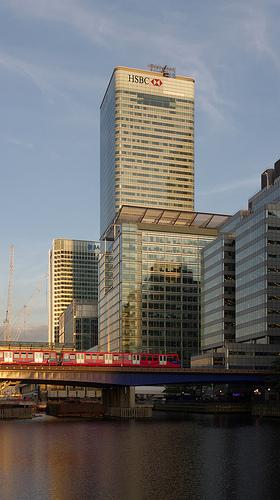Identify any modes of transportation visible in the image. A train is the primary mode of transportation visible in the image. Mention an object in the image that has two different colors. A red and blue train is an object with two colors in the image. Estimate the dimensions of the tall building in the picture. The tall building is approximately 80 units wide and 80 units high. What type of scene is predominantly in the image? An urban scene with a train on a bridge, tall building, and a clear blue sky. What is a remarkable aspect visible in the lower part of the image? A noticeable reflection of a bridge appears in the water below it. Please tell me what you see on the train in this image. A red and blue train with a white door on it, crossing a bridge. What interactions can be observed between different objects in the image? Interactions include the train crossing the bridge, the reflection of the bridge in the water, and a crane near a tall building. What emotions might a viewer of this image feel? The viewer might feel a sense of calm due to the clear blue sky and water or excitement from the train crossing the bridge. Count the number of clouds in the image. The image has 13 individual clouds captured in it. Can you identify the primary colors present in the sky of this image? Blue and white are the primary colors in this image's sky, with white clouds scattered throughout. Is there a graffiti artwork on the tall building located at coordinates X:122, Y:70, Width:80, Height:80? The given information only indicates that there's a tall building, without making any reference to graffiti artwork. Hence, mentioning graffiti on the building is misleading. What type of door is found on the train? A white door Select the phrase that correctly describes an object in the image: "orange bike," "white and orange crane," "pink car." White and orange crane What is the main event happening in this scene? A red and blue train passing over a blue railroad bridge. What appears under the bridge in the image? There's another bridge under the bridge. Is there a reflection in the windows and water in the image? Yes, there is a reflection in both the windows and the water. Which of these objects is present in the image: a boat, a train, a bicycle? A train Is there a train in the image? If so, what colors are present on the train? Yes, there is a train in the image. It is red and blue. Do the white clouds appear in different parts of the sky in the image? Yes, the white clouds appear in various parts of the blue sky. Which object in the image best represents the color blue? Blue railroad bridge Is the sky filled with clouds? Yes, there are white clouds in the blue sky. Is there a green tree near the white and orange crane with the given coordinates X:3, Y:240, Width:47, Height:47? No, it's not mentioned in the image. Describe the activity of the tall building in the image. Unidentified activity, as no specific details are given about the tall building. What does the writing on the building say? Unable to determine as no text information is provided. Can you spot a group of people standing next to a red and blue train at coordinates X:2, Y:352, Width:175, Height:175?  Although a red and blue train is indeed mentioned in the given information, there's no reference to a group of people standing next to that train, making this instruction misleading. Is there a sign on the building? If yes, what are its colors? Yes, there is a black and white sign on the building. What type of bridge is in the image? A blue railroad bridge What is the primary color of the sky in the image? Clear blue Write a poetic description of the sky in the image. White clouds dancing gracefully in the clear blue vastness above. Do you see a multicolored hot air balloon in the clear blue sky located at X:11, Y:3, Width:268, Height:268? The given information only refers to a clear blue sky and clouds, without any mention of a hot air balloon, making this instruction misleading by adding an element not present in the image. Identify the primary color of the crane in the image. White and orange Describe an event happening in the image. A train is crossing a bridge. 